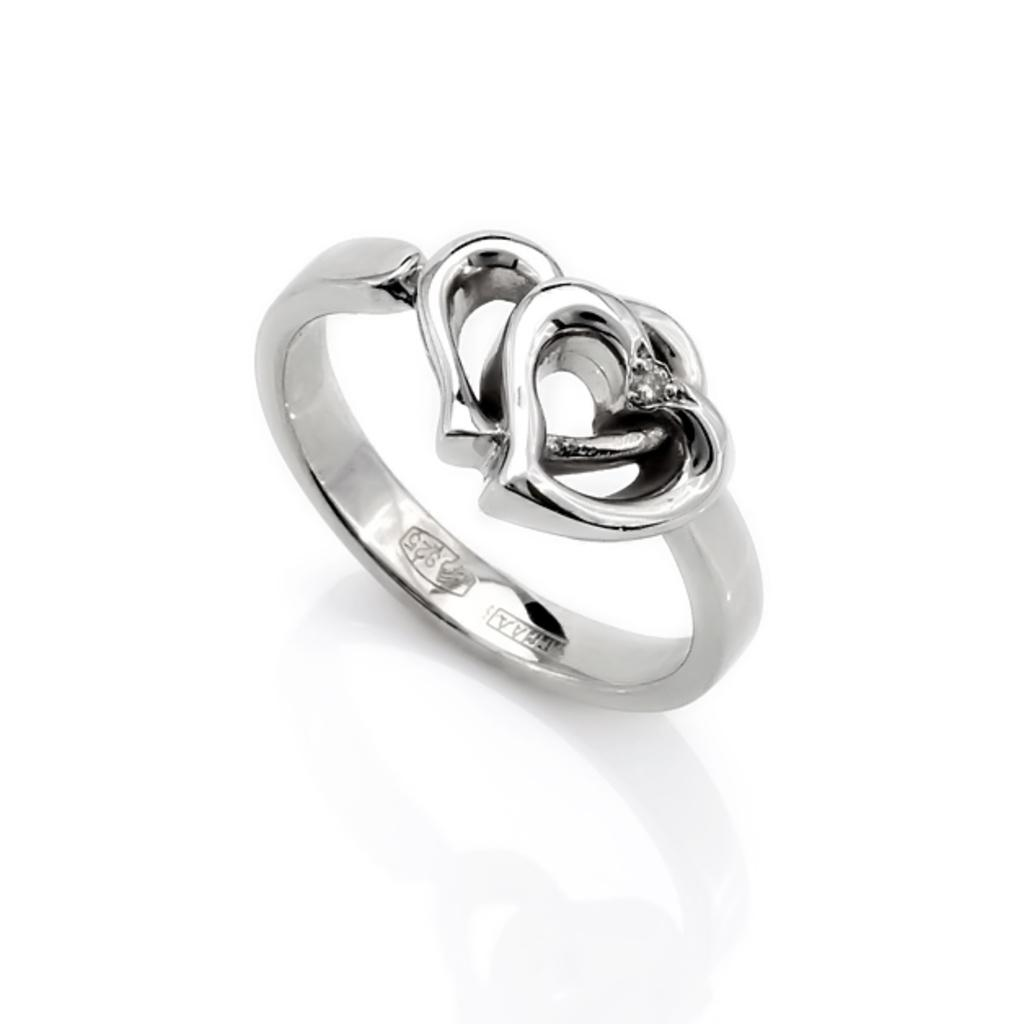What is the main object in the image? There is a ring in the image. What color is the background of the image? The background of the image is white. How many passengers are visible in the image? There are no passengers present in the image; it only features a ring against a white background. What type of corn can be seen growing in the image? There is no corn present in the image; it only features a ring against a white background. 